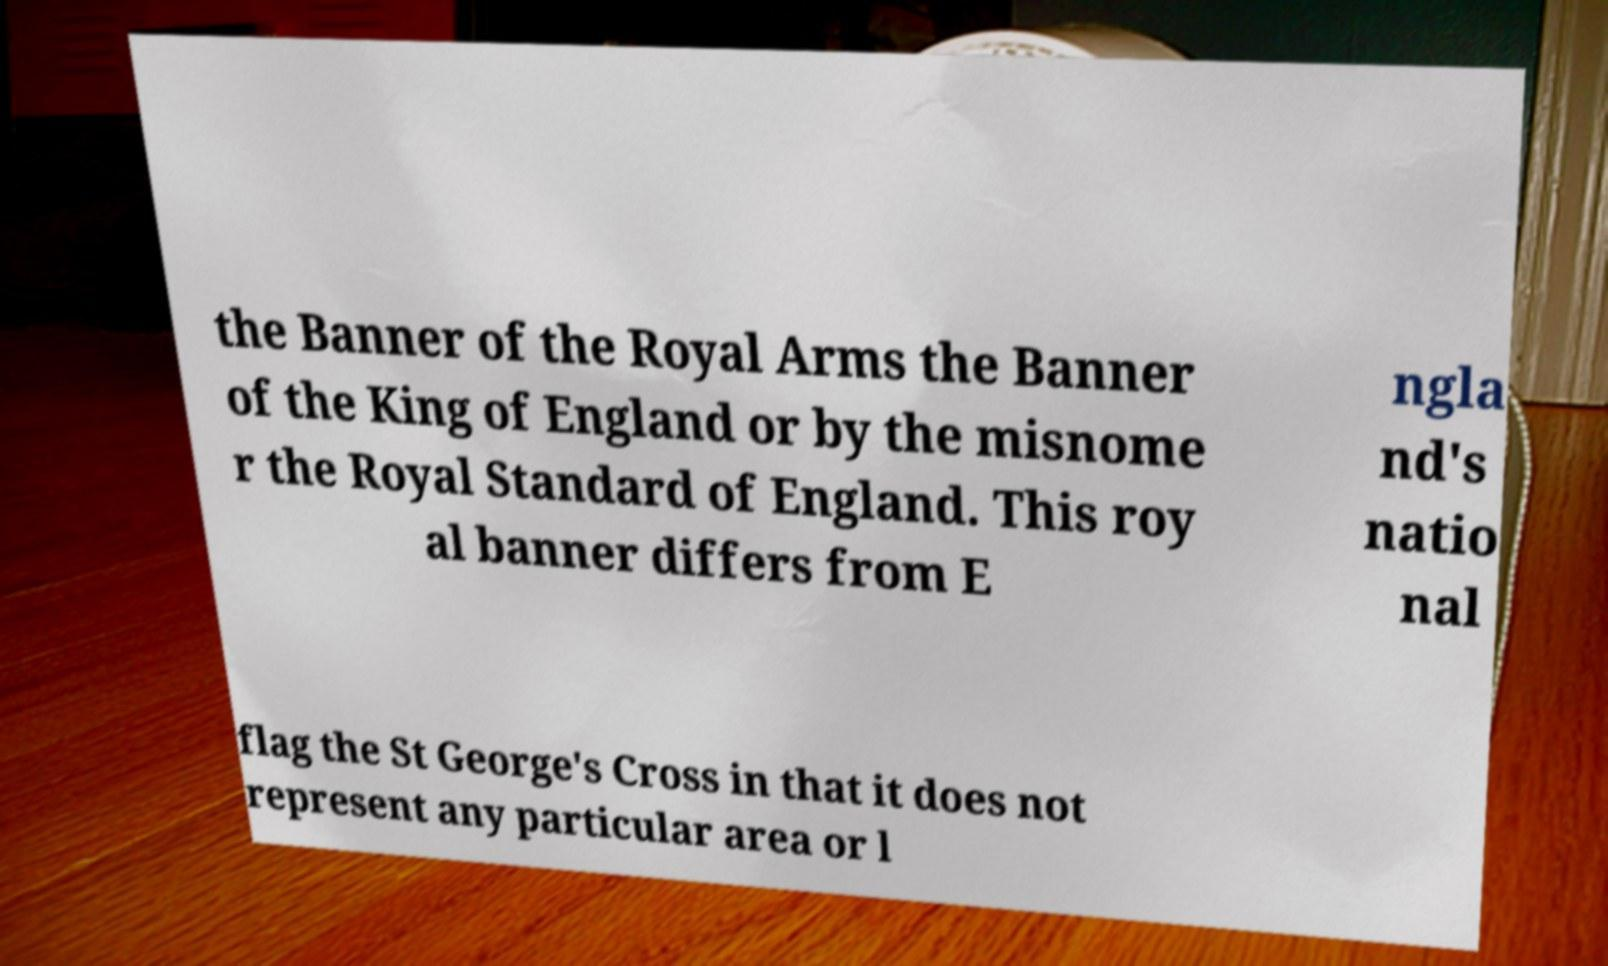Please identify and transcribe the text found in this image. the Banner of the Royal Arms the Banner of the King of England or by the misnome r the Royal Standard of England. This roy al banner differs from E ngla nd's natio nal flag the St George's Cross in that it does not represent any particular area or l 